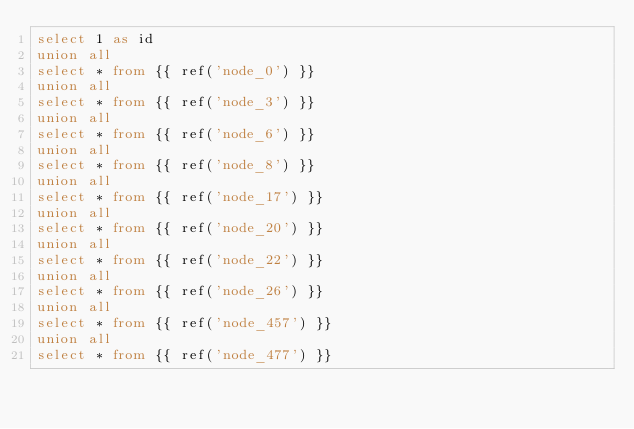Convert code to text. <code><loc_0><loc_0><loc_500><loc_500><_SQL_>select 1 as id
union all
select * from {{ ref('node_0') }}
union all
select * from {{ ref('node_3') }}
union all
select * from {{ ref('node_6') }}
union all
select * from {{ ref('node_8') }}
union all
select * from {{ ref('node_17') }}
union all
select * from {{ ref('node_20') }}
union all
select * from {{ ref('node_22') }}
union all
select * from {{ ref('node_26') }}
union all
select * from {{ ref('node_457') }}
union all
select * from {{ ref('node_477') }}</code> 